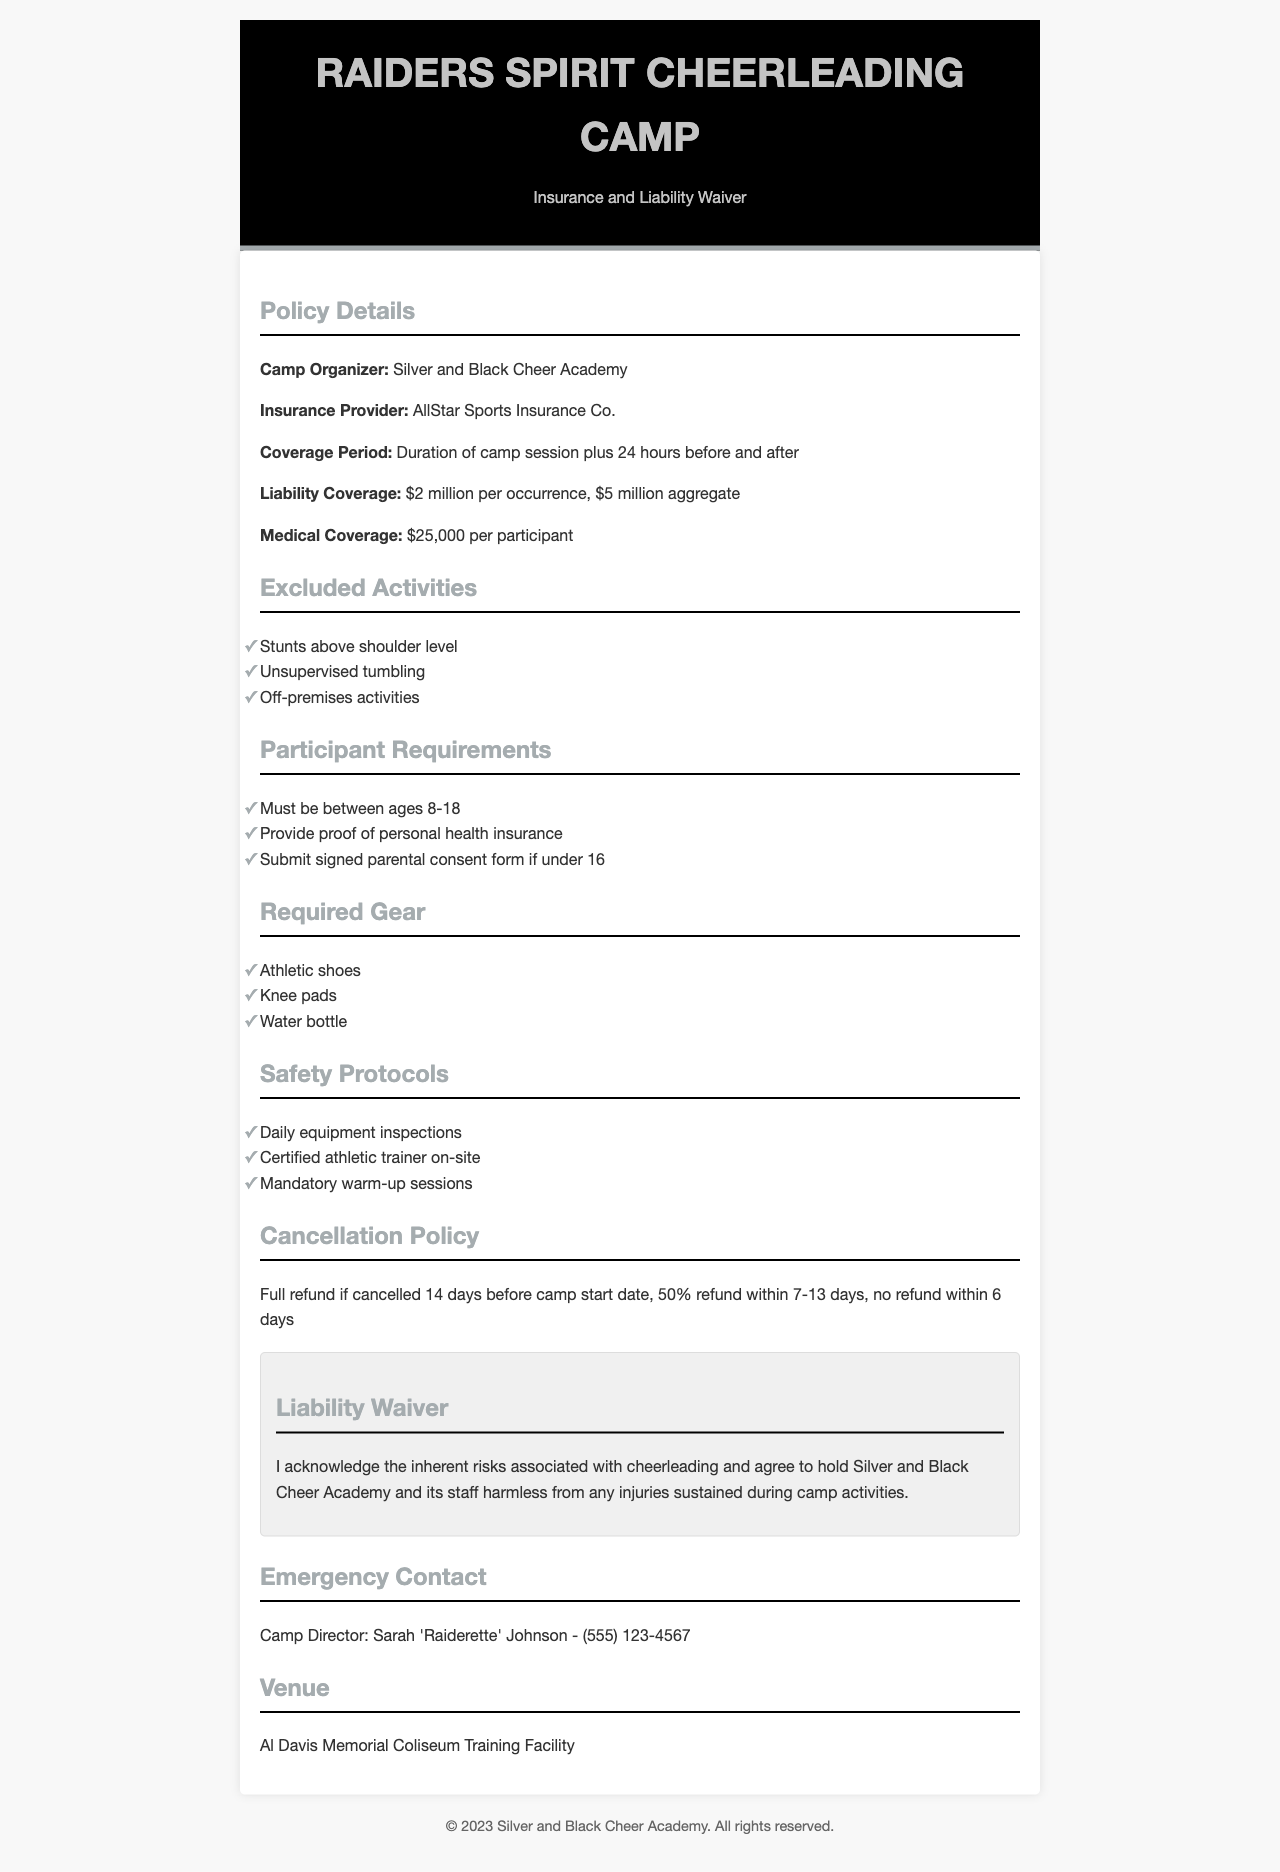What is the camp organizer's name? The camp organizer is identified within the document under "Camp Organizer."
Answer: Silver and Black Cheer Academy What is the liability coverage amount per occurrence? This refers to the amount of coverage provided per incident as stated in the "Liability Coverage" section.
Answer: $2 million What age range must participants fall within? This information is found under "Participant Requirements" and specifies the minimum and maximum ages allowed.
Answer: 8-18 What is the maximum medical coverage per participant? The maximum medical coverage is specified under "Medical Coverage" in the document.
Answer: $25,000 What is the refund policy for cancellations made within 6 days? This is detailed in the "Cancellation Policy" section and indicates the refund status at that time.
Answer: No refund Which venue hosts the cheerleading camp? The venue is mentioned in the "Venue" section of the document.
Answer: Al Davis Memorial Coliseum Training Facility What is a required safety protocol mentioned in the document? This asks for a specific safety protocol that is listed under "Safety Protocols."
Answer: Daily equipment inspections Is a signed parental consent form required for participants under 16? This is found in the "Participant Requirements," indicating whether it's mandatory.
Answer: Yes 